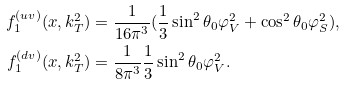Convert formula to latex. <formula><loc_0><loc_0><loc_500><loc_500>f _ { 1 } ^ { ( u v ) } ( x , k _ { T } ^ { 2 } ) & = \frac { 1 } { 1 6 \pi ^ { 3 } } ( \frac { 1 } { 3 } \sin ^ { 2 } \theta _ { 0 } \varphi _ { V } ^ { 2 } + \cos ^ { 2 } \theta _ { 0 } \varphi _ { S } ^ { 2 } ) , \\ f _ { 1 } ^ { ( d v ) } ( x , k _ { T } ^ { 2 } ) & = \frac { 1 } { 8 \pi ^ { 3 } } \frac { 1 } { 3 } \sin ^ { 2 } \theta _ { 0 } \varphi _ { V } ^ { 2 } .</formula> 